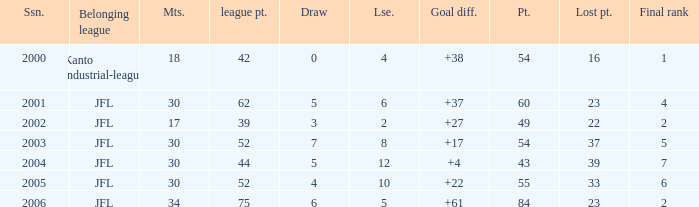Tell me the highest matches for point 43 and final rank less than 7 None. 